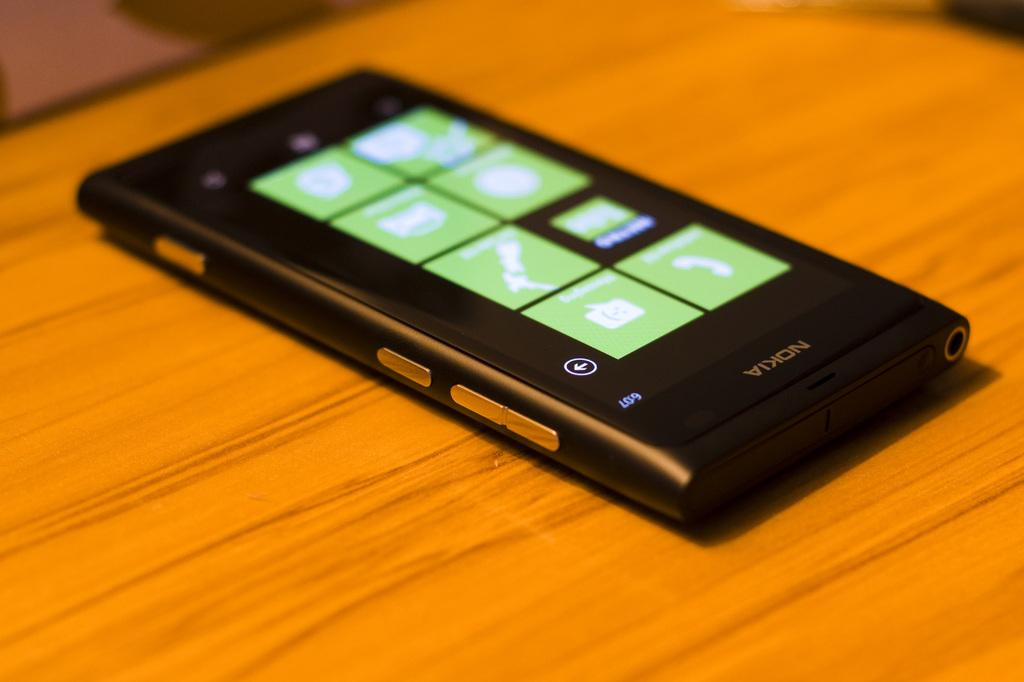<image>
Offer a succinct explanation of the picture presented. a black and silver nokia phone with the message app on the screen 